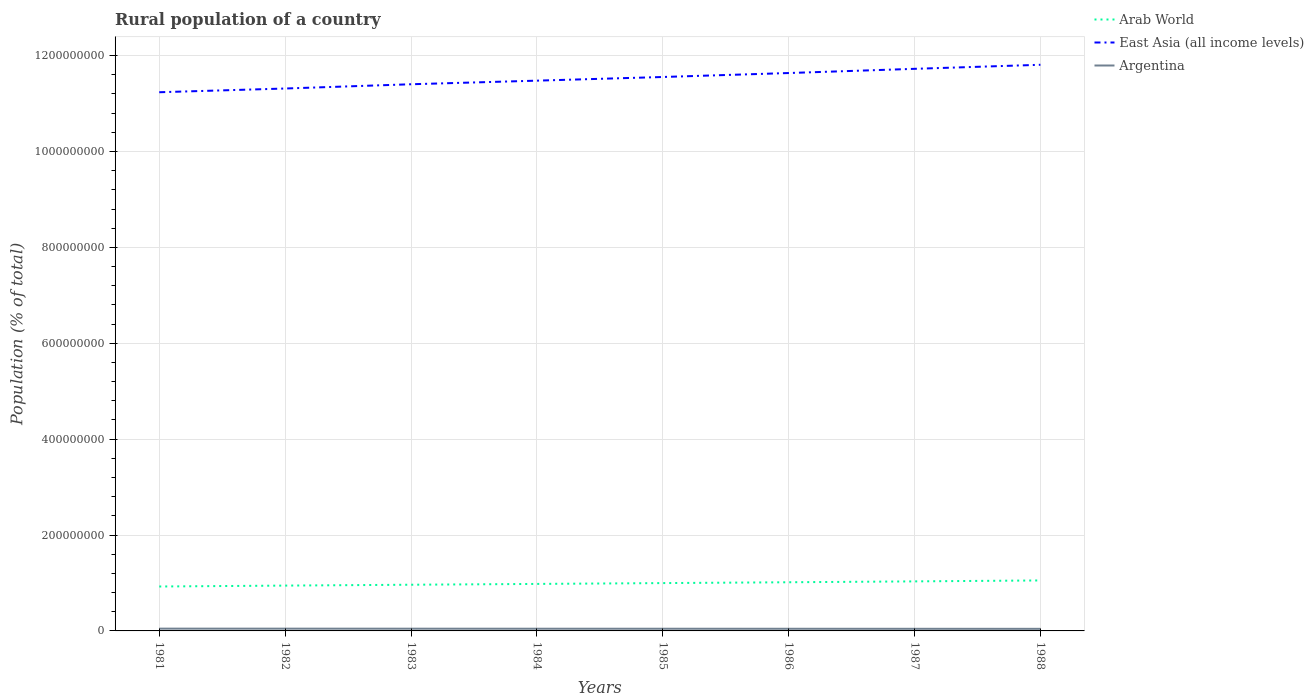Does the line corresponding to Arab World intersect with the line corresponding to East Asia (all income levels)?
Offer a terse response. No. Is the number of lines equal to the number of legend labels?
Your answer should be very brief. Yes. Across all years, what is the maximum rural population in Arab World?
Make the answer very short. 9.27e+07. What is the total rural population in Argentina in the graph?
Give a very brief answer. 1.07e+05. What is the difference between the highest and the second highest rural population in East Asia (all income levels)?
Make the answer very short. 5.73e+07. What is the difference between the highest and the lowest rural population in Argentina?
Offer a terse response. 4. Is the rural population in Arab World strictly greater than the rural population in Argentina over the years?
Ensure brevity in your answer.  No. How many years are there in the graph?
Keep it short and to the point. 8. Does the graph contain any zero values?
Your response must be concise. No. Where does the legend appear in the graph?
Your response must be concise. Top right. How are the legend labels stacked?
Offer a terse response. Vertical. What is the title of the graph?
Make the answer very short. Rural population of a country. Does "Egypt, Arab Rep." appear as one of the legend labels in the graph?
Offer a very short reply. No. What is the label or title of the X-axis?
Provide a succinct answer. Years. What is the label or title of the Y-axis?
Offer a very short reply. Population (% of total). What is the Population (% of total) in Arab World in 1981?
Ensure brevity in your answer.  9.27e+07. What is the Population (% of total) of East Asia (all income levels) in 1981?
Your response must be concise. 1.12e+09. What is the Population (% of total) in Argentina in 1981?
Your response must be concise. 4.76e+06. What is the Population (% of total) in Arab World in 1982?
Offer a terse response. 9.46e+07. What is the Population (% of total) of East Asia (all income levels) in 1982?
Keep it short and to the point. 1.13e+09. What is the Population (% of total) of Argentina in 1982?
Make the answer very short. 4.71e+06. What is the Population (% of total) of Arab World in 1983?
Provide a short and direct response. 9.64e+07. What is the Population (% of total) of East Asia (all income levels) in 1983?
Ensure brevity in your answer.  1.14e+09. What is the Population (% of total) of Argentina in 1983?
Your answer should be very brief. 4.66e+06. What is the Population (% of total) of Arab World in 1984?
Your answer should be very brief. 9.80e+07. What is the Population (% of total) in East Asia (all income levels) in 1984?
Ensure brevity in your answer.  1.15e+09. What is the Population (% of total) in Argentina in 1984?
Offer a very short reply. 4.60e+06. What is the Population (% of total) of Arab World in 1985?
Your answer should be compact. 9.98e+07. What is the Population (% of total) of East Asia (all income levels) in 1985?
Offer a very short reply. 1.16e+09. What is the Population (% of total) in Argentina in 1985?
Offer a very short reply. 4.55e+06. What is the Population (% of total) in Arab World in 1986?
Give a very brief answer. 1.02e+08. What is the Population (% of total) in East Asia (all income levels) in 1986?
Your answer should be compact. 1.16e+09. What is the Population (% of total) in Argentina in 1986?
Provide a succinct answer. 4.49e+06. What is the Population (% of total) in Arab World in 1987?
Your answer should be very brief. 1.03e+08. What is the Population (% of total) of East Asia (all income levels) in 1987?
Your answer should be very brief. 1.17e+09. What is the Population (% of total) in Argentina in 1987?
Your answer should be compact. 4.43e+06. What is the Population (% of total) in Arab World in 1988?
Ensure brevity in your answer.  1.05e+08. What is the Population (% of total) of East Asia (all income levels) in 1988?
Provide a short and direct response. 1.18e+09. What is the Population (% of total) in Argentina in 1988?
Your response must be concise. 4.38e+06. Across all years, what is the maximum Population (% of total) of Arab World?
Offer a terse response. 1.05e+08. Across all years, what is the maximum Population (% of total) of East Asia (all income levels)?
Make the answer very short. 1.18e+09. Across all years, what is the maximum Population (% of total) of Argentina?
Your response must be concise. 4.76e+06. Across all years, what is the minimum Population (% of total) in Arab World?
Provide a succinct answer. 9.27e+07. Across all years, what is the minimum Population (% of total) in East Asia (all income levels)?
Your answer should be compact. 1.12e+09. Across all years, what is the minimum Population (% of total) in Argentina?
Your response must be concise. 4.38e+06. What is the total Population (% of total) in Arab World in the graph?
Your answer should be very brief. 7.92e+08. What is the total Population (% of total) in East Asia (all income levels) in the graph?
Your answer should be very brief. 9.22e+09. What is the total Population (% of total) in Argentina in the graph?
Your answer should be very brief. 3.66e+07. What is the difference between the Population (% of total) of Arab World in 1981 and that in 1982?
Ensure brevity in your answer.  -1.89e+06. What is the difference between the Population (% of total) of East Asia (all income levels) in 1981 and that in 1982?
Offer a terse response. -7.75e+06. What is the difference between the Population (% of total) of Argentina in 1981 and that in 1982?
Keep it short and to the point. 5.41e+04. What is the difference between the Population (% of total) in Arab World in 1981 and that in 1983?
Keep it short and to the point. -3.70e+06. What is the difference between the Population (% of total) of East Asia (all income levels) in 1981 and that in 1983?
Ensure brevity in your answer.  -1.66e+07. What is the difference between the Population (% of total) in Argentina in 1981 and that in 1983?
Your answer should be compact. 1.07e+05. What is the difference between the Population (% of total) in Arab World in 1981 and that in 1984?
Your response must be concise. -5.38e+06. What is the difference between the Population (% of total) of East Asia (all income levels) in 1981 and that in 1984?
Offer a terse response. -2.42e+07. What is the difference between the Population (% of total) in Argentina in 1981 and that in 1984?
Your answer should be compact. 1.61e+05. What is the difference between the Population (% of total) in Arab World in 1981 and that in 1985?
Offer a terse response. -7.12e+06. What is the difference between the Population (% of total) of East Asia (all income levels) in 1981 and that in 1985?
Provide a succinct answer. -3.18e+07. What is the difference between the Population (% of total) in Argentina in 1981 and that in 1985?
Offer a very short reply. 2.16e+05. What is the difference between the Population (% of total) in Arab World in 1981 and that in 1986?
Make the answer very short. -8.86e+06. What is the difference between the Population (% of total) of East Asia (all income levels) in 1981 and that in 1986?
Your response must be concise. -4.01e+07. What is the difference between the Population (% of total) in Argentina in 1981 and that in 1986?
Your response must be concise. 2.72e+05. What is the difference between the Population (% of total) of Arab World in 1981 and that in 1987?
Offer a very short reply. -1.07e+07. What is the difference between the Population (% of total) of East Asia (all income levels) in 1981 and that in 1987?
Provide a short and direct response. -4.88e+07. What is the difference between the Population (% of total) in Argentina in 1981 and that in 1987?
Your answer should be compact. 3.28e+05. What is the difference between the Population (% of total) of Arab World in 1981 and that in 1988?
Provide a short and direct response. -1.26e+07. What is the difference between the Population (% of total) in East Asia (all income levels) in 1981 and that in 1988?
Your answer should be compact. -5.73e+07. What is the difference between the Population (% of total) in Argentina in 1981 and that in 1988?
Your answer should be compact. 3.86e+05. What is the difference between the Population (% of total) of Arab World in 1982 and that in 1983?
Keep it short and to the point. -1.80e+06. What is the difference between the Population (% of total) of East Asia (all income levels) in 1982 and that in 1983?
Your response must be concise. -8.88e+06. What is the difference between the Population (% of total) in Argentina in 1982 and that in 1983?
Your answer should be compact. 5.33e+04. What is the difference between the Population (% of total) of Arab World in 1982 and that in 1984?
Offer a very short reply. -3.49e+06. What is the difference between the Population (% of total) in East Asia (all income levels) in 1982 and that in 1984?
Your response must be concise. -1.64e+07. What is the difference between the Population (% of total) of Argentina in 1982 and that in 1984?
Provide a succinct answer. 1.07e+05. What is the difference between the Population (% of total) of Arab World in 1982 and that in 1985?
Your answer should be very brief. -5.23e+06. What is the difference between the Population (% of total) of East Asia (all income levels) in 1982 and that in 1985?
Ensure brevity in your answer.  -2.40e+07. What is the difference between the Population (% of total) in Argentina in 1982 and that in 1985?
Provide a succinct answer. 1.62e+05. What is the difference between the Population (% of total) in Arab World in 1982 and that in 1986?
Provide a short and direct response. -6.97e+06. What is the difference between the Population (% of total) in East Asia (all income levels) in 1982 and that in 1986?
Your response must be concise. -3.23e+07. What is the difference between the Population (% of total) of Argentina in 1982 and that in 1986?
Offer a very short reply. 2.18e+05. What is the difference between the Population (% of total) of Arab World in 1982 and that in 1987?
Make the answer very short. -8.79e+06. What is the difference between the Population (% of total) in East Asia (all income levels) in 1982 and that in 1987?
Your response must be concise. -4.11e+07. What is the difference between the Population (% of total) in Argentina in 1982 and that in 1987?
Offer a terse response. 2.74e+05. What is the difference between the Population (% of total) in Arab World in 1982 and that in 1988?
Offer a terse response. -1.07e+07. What is the difference between the Population (% of total) in East Asia (all income levels) in 1982 and that in 1988?
Make the answer very short. -4.95e+07. What is the difference between the Population (% of total) in Argentina in 1982 and that in 1988?
Your answer should be very brief. 3.32e+05. What is the difference between the Population (% of total) of Arab World in 1983 and that in 1984?
Your answer should be very brief. -1.68e+06. What is the difference between the Population (% of total) of East Asia (all income levels) in 1983 and that in 1984?
Ensure brevity in your answer.  -7.51e+06. What is the difference between the Population (% of total) in Argentina in 1983 and that in 1984?
Offer a terse response. 5.41e+04. What is the difference between the Population (% of total) of Arab World in 1983 and that in 1985?
Offer a very short reply. -3.42e+06. What is the difference between the Population (% of total) of East Asia (all income levels) in 1983 and that in 1985?
Give a very brief answer. -1.52e+07. What is the difference between the Population (% of total) in Argentina in 1983 and that in 1985?
Your answer should be compact. 1.09e+05. What is the difference between the Population (% of total) in Arab World in 1983 and that in 1986?
Your response must be concise. -5.16e+06. What is the difference between the Population (% of total) in East Asia (all income levels) in 1983 and that in 1986?
Ensure brevity in your answer.  -2.34e+07. What is the difference between the Population (% of total) in Argentina in 1983 and that in 1986?
Your response must be concise. 1.64e+05. What is the difference between the Population (% of total) of Arab World in 1983 and that in 1987?
Your answer should be very brief. -6.98e+06. What is the difference between the Population (% of total) in East Asia (all income levels) in 1983 and that in 1987?
Offer a terse response. -3.22e+07. What is the difference between the Population (% of total) in Argentina in 1983 and that in 1987?
Offer a terse response. 2.21e+05. What is the difference between the Population (% of total) in Arab World in 1983 and that in 1988?
Your answer should be very brief. -8.94e+06. What is the difference between the Population (% of total) in East Asia (all income levels) in 1983 and that in 1988?
Give a very brief answer. -4.06e+07. What is the difference between the Population (% of total) of Argentina in 1983 and that in 1988?
Provide a short and direct response. 2.78e+05. What is the difference between the Population (% of total) of Arab World in 1984 and that in 1985?
Offer a terse response. -1.74e+06. What is the difference between the Population (% of total) of East Asia (all income levels) in 1984 and that in 1985?
Provide a short and direct response. -7.64e+06. What is the difference between the Population (% of total) in Argentina in 1984 and that in 1985?
Offer a terse response. 5.48e+04. What is the difference between the Population (% of total) in Arab World in 1984 and that in 1986?
Give a very brief answer. -3.48e+06. What is the difference between the Population (% of total) in East Asia (all income levels) in 1984 and that in 1986?
Give a very brief answer. -1.59e+07. What is the difference between the Population (% of total) of Argentina in 1984 and that in 1986?
Your response must be concise. 1.10e+05. What is the difference between the Population (% of total) in Arab World in 1984 and that in 1987?
Make the answer very short. -5.30e+06. What is the difference between the Population (% of total) of East Asia (all income levels) in 1984 and that in 1987?
Keep it short and to the point. -2.47e+07. What is the difference between the Population (% of total) in Argentina in 1984 and that in 1987?
Keep it short and to the point. 1.67e+05. What is the difference between the Population (% of total) of Arab World in 1984 and that in 1988?
Offer a very short reply. -7.25e+06. What is the difference between the Population (% of total) of East Asia (all income levels) in 1984 and that in 1988?
Your response must be concise. -3.31e+07. What is the difference between the Population (% of total) in Argentina in 1984 and that in 1988?
Offer a terse response. 2.24e+05. What is the difference between the Population (% of total) of Arab World in 1985 and that in 1986?
Ensure brevity in your answer.  -1.74e+06. What is the difference between the Population (% of total) in East Asia (all income levels) in 1985 and that in 1986?
Ensure brevity in your answer.  -8.27e+06. What is the difference between the Population (% of total) in Argentina in 1985 and that in 1986?
Make the answer very short. 5.55e+04. What is the difference between the Population (% of total) in Arab World in 1985 and that in 1987?
Offer a very short reply. -3.56e+06. What is the difference between the Population (% of total) in East Asia (all income levels) in 1985 and that in 1987?
Your answer should be very brief. -1.70e+07. What is the difference between the Population (% of total) of Argentina in 1985 and that in 1987?
Provide a short and direct response. 1.12e+05. What is the difference between the Population (% of total) of Arab World in 1985 and that in 1988?
Ensure brevity in your answer.  -5.51e+06. What is the difference between the Population (% of total) of East Asia (all income levels) in 1985 and that in 1988?
Ensure brevity in your answer.  -2.55e+07. What is the difference between the Population (% of total) in Argentina in 1985 and that in 1988?
Keep it short and to the point. 1.69e+05. What is the difference between the Population (% of total) of Arab World in 1986 and that in 1987?
Offer a terse response. -1.82e+06. What is the difference between the Population (% of total) of East Asia (all income levels) in 1986 and that in 1987?
Give a very brief answer. -8.75e+06. What is the difference between the Population (% of total) in Argentina in 1986 and that in 1987?
Ensure brevity in your answer.  5.64e+04. What is the difference between the Population (% of total) of Arab World in 1986 and that in 1988?
Ensure brevity in your answer.  -3.77e+06. What is the difference between the Population (% of total) in East Asia (all income levels) in 1986 and that in 1988?
Make the answer very short. -1.72e+07. What is the difference between the Population (% of total) in Argentina in 1986 and that in 1988?
Make the answer very short. 1.14e+05. What is the difference between the Population (% of total) in Arab World in 1987 and that in 1988?
Your answer should be very brief. -1.95e+06. What is the difference between the Population (% of total) of East Asia (all income levels) in 1987 and that in 1988?
Your answer should be compact. -8.46e+06. What is the difference between the Population (% of total) in Argentina in 1987 and that in 1988?
Make the answer very short. 5.76e+04. What is the difference between the Population (% of total) in Arab World in 1981 and the Population (% of total) in East Asia (all income levels) in 1982?
Make the answer very short. -1.04e+09. What is the difference between the Population (% of total) of Arab World in 1981 and the Population (% of total) of Argentina in 1982?
Offer a very short reply. 8.80e+07. What is the difference between the Population (% of total) of East Asia (all income levels) in 1981 and the Population (% of total) of Argentina in 1982?
Your answer should be very brief. 1.12e+09. What is the difference between the Population (% of total) in Arab World in 1981 and the Population (% of total) in East Asia (all income levels) in 1983?
Make the answer very short. -1.05e+09. What is the difference between the Population (% of total) in Arab World in 1981 and the Population (% of total) in Argentina in 1983?
Offer a terse response. 8.80e+07. What is the difference between the Population (% of total) in East Asia (all income levels) in 1981 and the Population (% of total) in Argentina in 1983?
Your answer should be very brief. 1.12e+09. What is the difference between the Population (% of total) of Arab World in 1981 and the Population (% of total) of East Asia (all income levels) in 1984?
Offer a terse response. -1.06e+09. What is the difference between the Population (% of total) in Arab World in 1981 and the Population (% of total) in Argentina in 1984?
Your response must be concise. 8.81e+07. What is the difference between the Population (% of total) in East Asia (all income levels) in 1981 and the Population (% of total) in Argentina in 1984?
Keep it short and to the point. 1.12e+09. What is the difference between the Population (% of total) of Arab World in 1981 and the Population (% of total) of East Asia (all income levels) in 1985?
Give a very brief answer. -1.06e+09. What is the difference between the Population (% of total) of Arab World in 1981 and the Population (% of total) of Argentina in 1985?
Your response must be concise. 8.81e+07. What is the difference between the Population (% of total) of East Asia (all income levels) in 1981 and the Population (% of total) of Argentina in 1985?
Offer a very short reply. 1.12e+09. What is the difference between the Population (% of total) in Arab World in 1981 and the Population (% of total) in East Asia (all income levels) in 1986?
Keep it short and to the point. -1.07e+09. What is the difference between the Population (% of total) of Arab World in 1981 and the Population (% of total) of Argentina in 1986?
Ensure brevity in your answer.  8.82e+07. What is the difference between the Population (% of total) of East Asia (all income levels) in 1981 and the Population (% of total) of Argentina in 1986?
Offer a very short reply. 1.12e+09. What is the difference between the Population (% of total) of Arab World in 1981 and the Population (% of total) of East Asia (all income levels) in 1987?
Give a very brief answer. -1.08e+09. What is the difference between the Population (% of total) in Arab World in 1981 and the Population (% of total) in Argentina in 1987?
Your response must be concise. 8.82e+07. What is the difference between the Population (% of total) of East Asia (all income levels) in 1981 and the Population (% of total) of Argentina in 1987?
Make the answer very short. 1.12e+09. What is the difference between the Population (% of total) in Arab World in 1981 and the Population (% of total) in East Asia (all income levels) in 1988?
Make the answer very short. -1.09e+09. What is the difference between the Population (% of total) in Arab World in 1981 and the Population (% of total) in Argentina in 1988?
Ensure brevity in your answer.  8.83e+07. What is the difference between the Population (% of total) in East Asia (all income levels) in 1981 and the Population (% of total) in Argentina in 1988?
Your response must be concise. 1.12e+09. What is the difference between the Population (% of total) in Arab World in 1982 and the Population (% of total) in East Asia (all income levels) in 1983?
Provide a succinct answer. -1.05e+09. What is the difference between the Population (% of total) of Arab World in 1982 and the Population (% of total) of Argentina in 1983?
Your answer should be very brief. 8.99e+07. What is the difference between the Population (% of total) of East Asia (all income levels) in 1982 and the Population (% of total) of Argentina in 1983?
Make the answer very short. 1.13e+09. What is the difference between the Population (% of total) in Arab World in 1982 and the Population (% of total) in East Asia (all income levels) in 1984?
Provide a succinct answer. -1.05e+09. What is the difference between the Population (% of total) in Arab World in 1982 and the Population (% of total) in Argentina in 1984?
Keep it short and to the point. 9.00e+07. What is the difference between the Population (% of total) of East Asia (all income levels) in 1982 and the Population (% of total) of Argentina in 1984?
Provide a short and direct response. 1.13e+09. What is the difference between the Population (% of total) in Arab World in 1982 and the Population (% of total) in East Asia (all income levels) in 1985?
Provide a short and direct response. -1.06e+09. What is the difference between the Population (% of total) of Arab World in 1982 and the Population (% of total) of Argentina in 1985?
Offer a terse response. 9.00e+07. What is the difference between the Population (% of total) in East Asia (all income levels) in 1982 and the Population (% of total) in Argentina in 1985?
Offer a very short reply. 1.13e+09. What is the difference between the Population (% of total) in Arab World in 1982 and the Population (% of total) in East Asia (all income levels) in 1986?
Offer a terse response. -1.07e+09. What is the difference between the Population (% of total) of Arab World in 1982 and the Population (% of total) of Argentina in 1986?
Offer a very short reply. 9.01e+07. What is the difference between the Population (% of total) of East Asia (all income levels) in 1982 and the Population (% of total) of Argentina in 1986?
Your response must be concise. 1.13e+09. What is the difference between the Population (% of total) of Arab World in 1982 and the Population (% of total) of East Asia (all income levels) in 1987?
Your answer should be compact. -1.08e+09. What is the difference between the Population (% of total) of Arab World in 1982 and the Population (% of total) of Argentina in 1987?
Give a very brief answer. 9.01e+07. What is the difference between the Population (% of total) of East Asia (all income levels) in 1982 and the Population (% of total) of Argentina in 1987?
Your answer should be compact. 1.13e+09. What is the difference between the Population (% of total) of Arab World in 1982 and the Population (% of total) of East Asia (all income levels) in 1988?
Offer a very short reply. -1.09e+09. What is the difference between the Population (% of total) in Arab World in 1982 and the Population (% of total) in Argentina in 1988?
Keep it short and to the point. 9.02e+07. What is the difference between the Population (% of total) of East Asia (all income levels) in 1982 and the Population (% of total) of Argentina in 1988?
Offer a terse response. 1.13e+09. What is the difference between the Population (% of total) of Arab World in 1983 and the Population (% of total) of East Asia (all income levels) in 1984?
Give a very brief answer. -1.05e+09. What is the difference between the Population (% of total) in Arab World in 1983 and the Population (% of total) in Argentina in 1984?
Give a very brief answer. 9.18e+07. What is the difference between the Population (% of total) of East Asia (all income levels) in 1983 and the Population (% of total) of Argentina in 1984?
Your answer should be compact. 1.14e+09. What is the difference between the Population (% of total) in Arab World in 1983 and the Population (% of total) in East Asia (all income levels) in 1985?
Offer a very short reply. -1.06e+09. What is the difference between the Population (% of total) of Arab World in 1983 and the Population (% of total) of Argentina in 1985?
Keep it short and to the point. 9.18e+07. What is the difference between the Population (% of total) in East Asia (all income levels) in 1983 and the Population (% of total) in Argentina in 1985?
Provide a short and direct response. 1.14e+09. What is the difference between the Population (% of total) of Arab World in 1983 and the Population (% of total) of East Asia (all income levels) in 1986?
Give a very brief answer. -1.07e+09. What is the difference between the Population (% of total) in Arab World in 1983 and the Population (% of total) in Argentina in 1986?
Give a very brief answer. 9.19e+07. What is the difference between the Population (% of total) in East Asia (all income levels) in 1983 and the Population (% of total) in Argentina in 1986?
Offer a terse response. 1.14e+09. What is the difference between the Population (% of total) of Arab World in 1983 and the Population (% of total) of East Asia (all income levels) in 1987?
Your answer should be compact. -1.08e+09. What is the difference between the Population (% of total) in Arab World in 1983 and the Population (% of total) in Argentina in 1987?
Ensure brevity in your answer.  9.19e+07. What is the difference between the Population (% of total) of East Asia (all income levels) in 1983 and the Population (% of total) of Argentina in 1987?
Make the answer very short. 1.14e+09. What is the difference between the Population (% of total) of Arab World in 1983 and the Population (% of total) of East Asia (all income levels) in 1988?
Provide a short and direct response. -1.08e+09. What is the difference between the Population (% of total) in Arab World in 1983 and the Population (% of total) in Argentina in 1988?
Provide a short and direct response. 9.20e+07. What is the difference between the Population (% of total) in East Asia (all income levels) in 1983 and the Population (% of total) in Argentina in 1988?
Provide a short and direct response. 1.14e+09. What is the difference between the Population (% of total) in Arab World in 1984 and the Population (% of total) in East Asia (all income levels) in 1985?
Make the answer very short. -1.06e+09. What is the difference between the Population (% of total) of Arab World in 1984 and the Population (% of total) of Argentina in 1985?
Offer a very short reply. 9.35e+07. What is the difference between the Population (% of total) of East Asia (all income levels) in 1984 and the Population (% of total) of Argentina in 1985?
Give a very brief answer. 1.14e+09. What is the difference between the Population (% of total) in Arab World in 1984 and the Population (% of total) in East Asia (all income levels) in 1986?
Your answer should be very brief. -1.07e+09. What is the difference between the Population (% of total) in Arab World in 1984 and the Population (% of total) in Argentina in 1986?
Provide a short and direct response. 9.35e+07. What is the difference between the Population (% of total) in East Asia (all income levels) in 1984 and the Population (% of total) in Argentina in 1986?
Make the answer very short. 1.14e+09. What is the difference between the Population (% of total) in Arab World in 1984 and the Population (% of total) in East Asia (all income levels) in 1987?
Provide a succinct answer. -1.07e+09. What is the difference between the Population (% of total) in Arab World in 1984 and the Population (% of total) in Argentina in 1987?
Offer a terse response. 9.36e+07. What is the difference between the Population (% of total) of East Asia (all income levels) in 1984 and the Population (% of total) of Argentina in 1987?
Provide a short and direct response. 1.14e+09. What is the difference between the Population (% of total) of Arab World in 1984 and the Population (% of total) of East Asia (all income levels) in 1988?
Provide a succinct answer. -1.08e+09. What is the difference between the Population (% of total) of Arab World in 1984 and the Population (% of total) of Argentina in 1988?
Provide a succinct answer. 9.37e+07. What is the difference between the Population (% of total) in East Asia (all income levels) in 1984 and the Population (% of total) in Argentina in 1988?
Give a very brief answer. 1.14e+09. What is the difference between the Population (% of total) in Arab World in 1985 and the Population (% of total) in East Asia (all income levels) in 1986?
Give a very brief answer. -1.06e+09. What is the difference between the Population (% of total) in Arab World in 1985 and the Population (% of total) in Argentina in 1986?
Keep it short and to the point. 9.53e+07. What is the difference between the Population (% of total) in East Asia (all income levels) in 1985 and the Population (% of total) in Argentina in 1986?
Make the answer very short. 1.15e+09. What is the difference between the Population (% of total) of Arab World in 1985 and the Population (% of total) of East Asia (all income levels) in 1987?
Keep it short and to the point. -1.07e+09. What is the difference between the Population (% of total) in Arab World in 1985 and the Population (% of total) in Argentina in 1987?
Give a very brief answer. 9.53e+07. What is the difference between the Population (% of total) in East Asia (all income levels) in 1985 and the Population (% of total) in Argentina in 1987?
Your answer should be very brief. 1.15e+09. What is the difference between the Population (% of total) in Arab World in 1985 and the Population (% of total) in East Asia (all income levels) in 1988?
Your answer should be compact. -1.08e+09. What is the difference between the Population (% of total) of Arab World in 1985 and the Population (% of total) of Argentina in 1988?
Ensure brevity in your answer.  9.54e+07. What is the difference between the Population (% of total) in East Asia (all income levels) in 1985 and the Population (% of total) in Argentina in 1988?
Your response must be concise. 1.15e+09. What is the difference between the Population (% of total) in Arab World in 1986 and the Population (% of total) in East Asia (all income levels) in 1987?
Offer a very short reply. -1.07e+09. What is the difference between the Population (% of total) in Arab World in 1986 and the Population (% of total) in Argentina in 1987?
Your answer should be compact. 9.71e+07. What is the difference between the Population (% of total) of East Asia (all income levels) in 1986 and the Population (% of total) of Argentina in 1987?
Your answer should be very brief. 1.16e+09. What is the difference between the Population (% of total) of Arab World in 1986 and the Population (% of total) of East Asia (all income levels) in 1988?
Offer a very short reply. -1.08e+09. What is the difference between the Population (% of total) in Arab World in 1986 and the Population (% of total) in Argentina in 1988?
Offer a terse response. 9.71e+07. What is the difference between the Population (% of total) in East Asia (all income levels) in 1986 and the Population (% of total) in Argentina in 1988?
Give a very brief answer. 1.16e+09. What is the difference between the Population (% of total) in Arab World in 1987 and the Population (% of total) in East Asia (all income levels) in 1988?
Keep it short and to the point. -1.08e+09. What is the difference between the Population (% of total) of Arab World in 1987 and the Population (% of total) of Argentina in 1988?
Ensure brevity in your answer.  9.90e+07. What is the difference between the Population (% of total) in East Asia (all income levels) in 1987 and the Population (% of total) in Argentina in 1988?
Your answer should be very brief. 1.17e+09. What is the average Population (% of total) in Arab World per year?
Make the answer very short. 9.89e+07. What is the average Population (% of total) of East Asia (all income levels) per year?
Offer a terse response. 1.15e+09. What is the average Population (% of total) in Argentina per year?
Provide a succinct answer. 4.57e+06. In the year 1981, what is the difference between the Population (% of total) of Arab World and Population (% of total) of East Asia (all income levels)?
Make the answer very short. -1.03e+09. In the year 1981, what is the difference between the Population (% of total) of Arab World and Population (% of total) of Argentina?
Offer a very short reply. 8.79e+07. In the year 1981, what is the difference between the Population (% of total) of East Asia (all income levels) and Population (% of total) of Argentina?
Give a very brief answer. 1.12e+09. In the year 1982, what is the difference between the Population (% of total) in Arab World and Population (% of total) in East Asia (all income levels)?
Offer a terse response. -1.04e+09. In the year 1982, what is the difference between the Population (% of total) of Arab World and Population (% of total) of Argentina?
Provide a short and direct response. 8.98e+07. In the year 1982, what is the difference between the Population (% of total) in East Asia (all income levels) and Population (% of total) in Argentina?
Your answer should be very brief. 1.13e+09. In the year 1983, what is the difference between the Population (% of total) in Arab World and Population (% of total) in East Asia (all income levels)?
Ensure brevity in your answer.  -1.04e+09. In the year 1983, what is the difference between the Population (% of total) of Arab World and Population (% of total) of Argentina?
Offer a very short reply. 9.17e+07. In the year 1983, what is the difference between the Population (% of total) of East Asia (all income levels) and Population (% of total) of Argentina?
Make the answer very short. 1.14e+09. In the year 1984, what is the difference between the Population (% of total) in Arab World and Population (% of total) in East Asia (all income levels)?
Offer a very short reply. -1.05e+09. In the year 1984, what is the difference between the Population (% of total) in Arab World and Population (% of total) in Argentina?
Give a very brief answer. 9.34e+07. In the year 1984, what is the difference between the Population (% of total) in East Asia (all income levels) and Population (% of total) in Argentina?
Give a very brief answer. 1.14e+09. In the year 1985, what is the difference between the Population (% of total) of Arab World and Population (% of total) of East Asia (all income levels)?
Your answer should be compact. -1.06e+09. In the year 1985, what is the difference between the Population (% of total) of Arab World and Population (% of total) of Argentina?
Your answer should be compact. 9.52e+07. In the year 1985, what is the difference between the Population (% of total) in East Asia (all income levels) and Population (% of total) in Argentina?
Your answer should be compact. 1.15e+09. In the year 1986, what is the difference between the Population (% of total) of Arab World and Population (% of total) of East Asia (all income levels)?
Provide a short and direct response. -1.06e+09. In the year 1986, what is the difference between the Population (% of total) in Arab World and Population (% of total) in Argentina?
Provide a short and direct response. 9.70e+07. In the year 1986, what is the difference between the Population (% of total) in East Asia (all income levels) and Population (% of total) in Argentina?
Your answer should be very brief. 1.16e+09. In the year 1987, what is the difference between the Population (% of total) in Arab World and Population (% of total) in East Asia (all income levels)?
Keep it short and to the point. -1.07e+09. In the year 1987, what is the difference between the Population (% of total) of Arab World and Population (% of total) of Argentina?
Your answer should be compact. 9.89e+07. In the year 1987, what is the difference between the Population (% of total) in East Asia (all income levels) and Population (% of total) in Argentina?
Your response must be concise. 1.17e+09. In the year 1988, what is the difference between the Population (% of total) of Arab World and Population (% of total) of East Asia (all income levels)?
Offer a very short reply. -1.08e+09. In the year 1988, what is the difference between the Population (% of total) of Arab World and Population (% of total) of Argentina?
Keep it short and to the point. 1.01e+08. In the year 1988, what is the difference between the Population (% of total) of East Asia (all income levels) and Population (% of total) of Argentina?
Keep it short and to the point. 1.18e+09. What is the ratio of the Population (% of total) in Arab World in 1981 to that in 1982?
Your answer should be compact. 0.98. What is the ratio of the Population (% of total) in Argentina in 1981 to that in 1982?
Provide a short and direct response. 1.01. What is the ratio of the Population (% of total) in Arab World in 1981 to that in 1983?
Offer a terse response. 0.96. What is the ratio of the Population (% of total) in East Asia (all income levels) in 1981 to that in 1983?
Offer a terse response. 0.99. What is the ratio of the Population (% of total) in Argentina in 1981 to that in 1983?
Offer a very short reply. 1.02. What is the ratio of the Population (% of total) in Arab World in 1981 to that in 1984?
Your response must be concise. 0.95. What is the ratio of the Population (% of total) of East Asia (all income levels) in 1981 to that in 1984?
Ensure brevity in your answer.  0.98. What is the ratio of the Population (% of total) in Argentina in 1981 to that in 1984?
Your answer should be very brief. 1.04. What is the ratio of the Population (% of total) in Arab World in 1981 to that in 1985?
Give a very brief answer. 0.93. What is the ratio of the Population (% of total) in East Asia (all income levels) in 1981 to that in 1985?
Ensure brevity in your answer.  0.97. What is the ratio of the Population (% of total) of Argentina in 1981 to that in 1985?
Your answer should be very brief. 1.05. What is the ratio of the Population (% of total) of Arab World in 1981 to that in 1986?
Ensure brevity in your answer.  0.91. What is the ratio of the Population (% of total) of East Asia (all income levels) in 1981 to that in 1986?
Give a very brief answer. 0.97. What is the ratio of the Population (% of total) of Argentina in 1981 to that in 1986?
Your response must be concise. 1.06. What is the ratio of the Population (% of total) in Arab World in 1981 to that in 1987?
Your response must be concise. 0.9. What is the ratio of the Population (% of total) in East Asia (all income levels) in 1981 to that in 1987?
Provide a succinct answer. 0.96. What is the ratio of the Population (% of total) of Argentina in 1981 to that in 1987?
Give a very brief answer. 1.07. What is the ratio of the Population (% of total) of Arab World in 1981 to that in 1988?
Your answer should be very brief. 0.88. What is the ratio of the Population (% of total) in East Asia (all income levels) in 1981 to that in 1988?
Give a very brief answer. 0.95. What is the ratio of the Population (% of total) in Argentina in 1981 to that in 1988?
Make the answer very short. 1.09. What is the ratio of the Population (% of total) in Arab World in 1982 to that in 1983?
Give a very brief answer. 0.98. What is the ratio of the Population (% of total) of East Asia (all income levels) in 1982 to that in 1983?
Provide a short and direct response. 0.99. What is the ratio of the Population (% of total) of Argentina in 1982 to that in 1983?
Give a very brief answer. 1.01. What is the ratio of the Population (% of total) of Arab World in 1982 to that in 1984?
Offer a very short reply. 0.96. What is the ratio of the Population (% of total) of East Asia (all income levels) in 1982 to that in 1984?
Your answer should be compact. 0.99. What is the ratio of the Population (% of total) in Argentina in 1982 to that in 1984?
Your answer should be very brief. 1.02. What is the ratio of the Population (% of total) in Arab World in 1982 to that in 1985?
Offer a very short reply. 0.95. What is the ratio of the Population (% of total) of East Asia (all income levels) in 1982 to that in 1985?
Your answer should be very brief. 0.98. What is the ratio of the Population (% of total) in Argentina in 1982 to that in 1985?
Your response must be concise. 1.04. What is the ratio of the Population (% of total) of Arab World in 1982 to that in 1986?
Provide a short and direct response. 0.93. What is the ratio of the Population (% of total) in East Asia (all income levels) in 1982 to that in 1986?
Provide a short and direct response. 0.97. What is the ratio of the Population (% of total) of Argentina in 1982 to that in 1986?
Your answer should be very brief. 1.05. What is the ratio of the Population (% of total) in Arab World in 1982 to that in 1987?
Offer a terse response. 0.92. What is the ratio of the Population (% of total) of East Asia (all income levels) in 1982 to that in 1987?
Provide a short and direct response. 0.96. What is the ratio of the Population (% of total) of Argentina in 1982 to that in 1987?
Keep it short and to the point. 1.06. What is the ratio of the Population (% of total) of Arab World in 1982 to that in 1988?
Make the answer very short. 0.9. What is the ratio of the Population (% of total) of East Asia (all income levels) in 1982 to that in 1988?
Your answer should be very brief. 0.96. What is the ratio of the Population (% of total) of Argentina in 1982 to that in 1988?
Provide a short and direct response. 1.08. What is the ratio of the Population (% of total) in Arab World in 1983 to that in 1984?
Your answer should be compact. 0.98. What is the ratio of the Population (% of total) of Argentina in 1983 to that in 1984?
Your answer should be compact. 1.01. What is the ratio of the Population (% of total) of Arab World in 1983 to that in 1985?
Your response must be concise. 0.97. What is the ratio of the Population (% of total) of East Asia (all income levels) in 1983 to that in 1985?
Ensure brevity in your answer.  0.99. What is the ratio of the Population (% of total) in Argentina in 1983 to that in 1985?
Offer a very short reply. 1.02. What is the ratio of the Population (% of total) in Arab World in 1983 to that in 1986?
Keep it short and to the point. 0.95. What is the ratio of the Population (% of total) of East Asia (all income levels) in 1983 to that in 1986?
Provide a short and direct response. 0.98. What is the ratio of the Population (% of total) of Argentina in 1983 to that in 1986?
Your answer should be very brief. 1.04. What is the ratio of the Population (% of total) of Arab World in 1983 to that in 1987?
Give a very brief answer. 0.93. What is the ratio of the Population (% of total) in East Asia (all income levels) in 1983 to that in 1987?
Your response must be concise. 0.97. What is the ratio of the Population (% of total) in Argentina in 1983 to that in 1987?
Ensure brevity in your answer.  1.05. What is the ratio of the Population (% of total) of Arab World in 1983 to that in 1988?
Make the answer very short. 0.92. What is the ratio of the Population (% of total) of East Asia (all income levels) in 1983 to that in 1988?
Your answer should be very brief. 0.97. What is the ratio of the Population (% of total) in Argentina in 1983 to that in 1988?
Provide a succinct answer. 1.06. What is the ratio of the Population (% of total) of Arab World in 1984 to that in 1985?
Keep it short and to the point. 0.98. What is the ratio of the Population (% of total) of Argentina in 1984 to that in 1985?
Your answer should be compact. 1.01. What is the ratio of the Population (% of total) of Arab World in 1984 to that in 1986?
Your answer should be very brief. 0.97. What is the ratio of the Population (% of total) of East Asia (all income levels) in 1984 to that in 1986?
Offer a very short reply. 0.99. What is the ratio of the Population (% of total) in Argentina in 1984 to that in 1986?
Ensure brevity in your answer.  1.02. What is the ratio of the Population (% of total) in Arab World in 1984 to that in 1987?
Provide a succinct answer. 0.95. What is the ratio of the Population (% of total) of Argentina in 1984 to that in 1987?
Provide a succinct answer. 1.04. What is the ratio of the Population (% of total) of Arab World in 1984 to that in 1988?
Provide a short and direct response. 0.93. What is the ratio of the Population (% of total) in East Asia (all income levels) in 1984 to that in 1988?
Make the answer very short. 0.97. What is the ratio of the Population (% of total) of Argentina in 1984 to that in 1988?
Your answer should be very brief. 1.05. What is the ratio of the Population (% of total) of Arab World in 1985 to that in 1986?
Your answer should be compact. 0.98. What is the ratio of the Population (% of total) of East Asia (all income levels) in 1985 to that in 1986?
Your response must be concise. 0.99. What is the ratio of the Population (% of total) of Argentina in 1985 to that in 1986?
Your response must be concise. 1.01. What is the ratio of the Population (% of total) of Arab World in 1985 to that in 1987?
Make the answer very short. 0.97. What is the ratio of the Population (% of total) of East Asia (all income levels) in 1985 to that in 1987?
Provide a short and direct response. 0.99. What is the ratio of the Population (% of total) of Argentina in 1985 to that in 1987?
Keep it short and to the point. 1.03. What is the ratio of the Population (% of total) in Arab World in 1985 to that in 1988?
Ensure brevity in your answer.  0.95. What is the ratio of the Population (% of total) in East Asia (all income levels) in 1985 to that in 1988?
Offer a very short reply. 0.98. What is the ratio of the Population (% of total) in Argentina in 1985 to that in 1988?
Offer a terse response. 1.04. What is the ratio of the Population (% of total) of Arab World in 1986 to that in 1987?
Give a very brief answer. 0.98. What is the ratio of the Population (% of total) of Argentina in 1986 to that in 1987?
Ensure brevity in your answer.  1.01. What is the ratio of the Population (% of total) of Arab World in 1986 to that in 1988?
Give a very brief answer. 0.96. What is the ratio of the Population (% of total) of East Asia (all income levels) in 1986 to that in 1988?
Your response must be concise. 0.99. What is the ratio of the Population (% of total) in Argentina in 1986 to that in 1988?
Your response must be concise. 1.03. What is the ratio of the Population (% of total) in Arab World in 1987 to that in 1988?
Make the answer very short. 0.98. What is the ratio of the Population (% of total) in Argentina in 1987 to that in 1988?
Give a very brief answer. 1.01. What is the difference between the highest and the second highest Population (% of total) in Arab World?
Provide a succinct answer. 1.95e+06. What is the difference between the highest and the second highest Population (% of total) in East Asia (all income levels)?
Your answer should be very brief. 8.46e+06. What is the difference between the highest and the second highest Population (% of total) in Argentina?
Give a very brief answer. 5.41e+04. What is the difference between the highest and the lowest Population (% of total) in Arab World?
Provide a short and direct response. 1.26e+07. What is the difference between the highest and the lowest Population (% of total) in East Asia (all income levels)?
Offer a very short reply. 5.73e+07. What is the difference between the highest and the lowest Population (% of total) in Argentina?
Provide a succinct answer. 3.86e+05. 